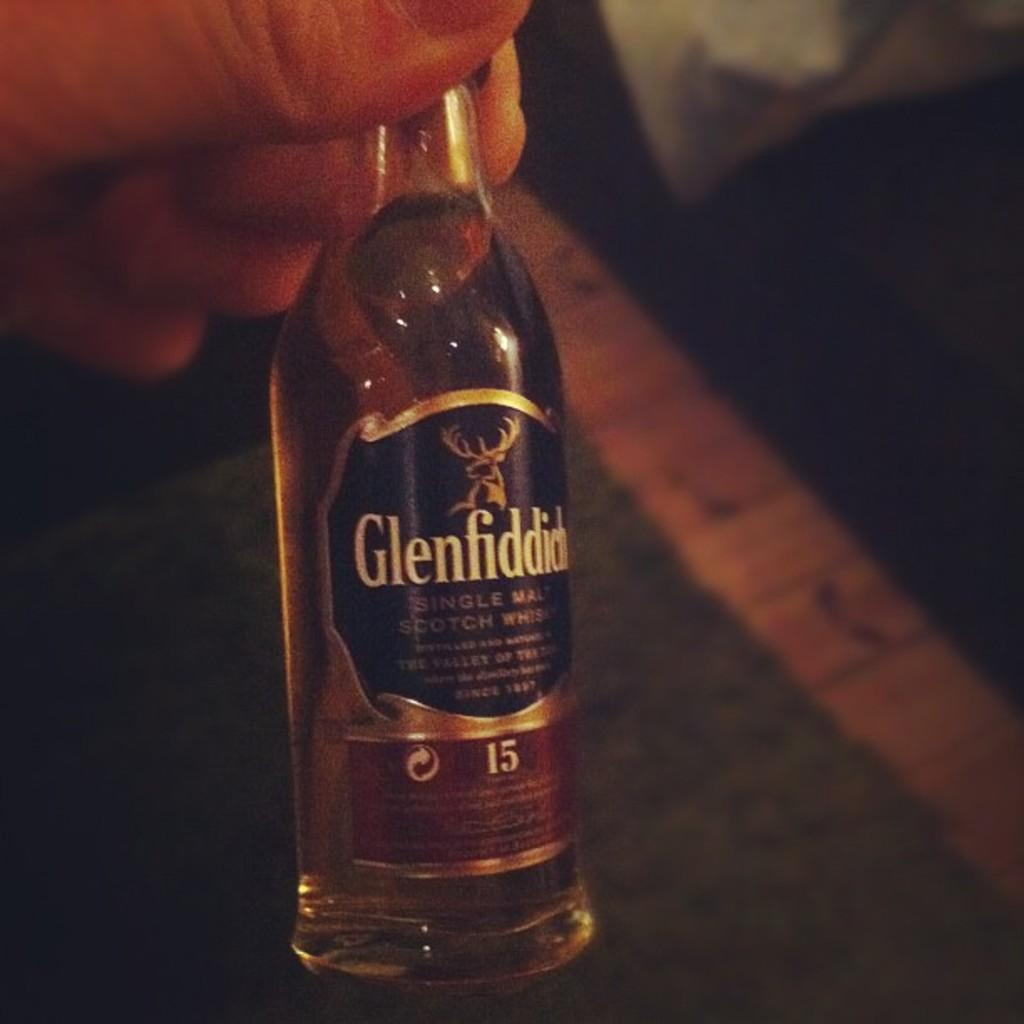What is the main object in the image? There is a small alcohol bottle in the image. What is inside the bottle? The bottle contains alcohol. Is there any information on the bottle? Yes, there is a label attached to the bottle. Who is holding the bottle in the image? A person is holding the bottle in their hand. How many cattle are visible in the image? There are no cattle present in the image. What type of agreement is being signed in the image? There is no agreement being signed in the image. 